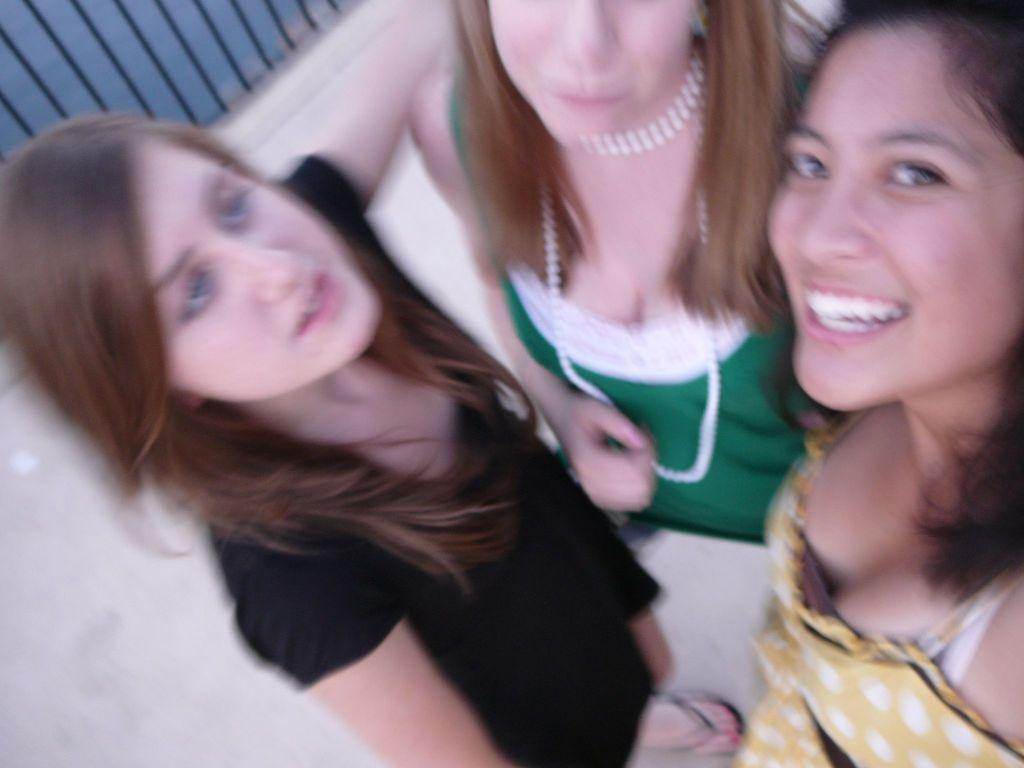How many women are present in the image? There are three women in the image. Can you describe the facial expression of one of the women? One of the women is smiling. What can be seen in the background of the image? There is a fence visible in the background of the image. Where is the crib located in the image? There is no crib present in the image. How many geese are visible in the image? There are no geese visible in the image. 